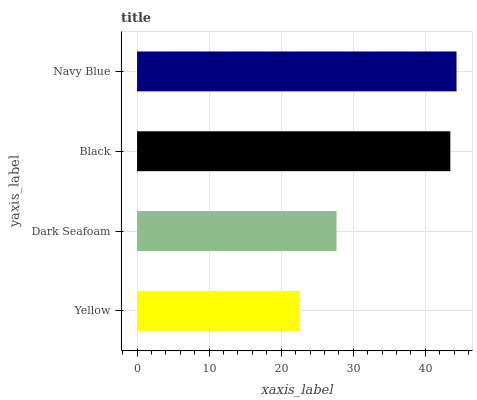Is Yellow the minimum?
Answer yes or no. Yes. Is Navy Blue the maximum?
Answer yes or no. Yes. Is Dark Seafoam the minimum?
Answer yes or no. No. Is Dark Seafoam the maximum?
Answer yes or no. No. Is Dark Seafoam greater than Yellow?
Answer yes or no. Yes. Is Yellow less than Dark Seafoam?
Answer yes or no. Yes. Is Yellow greater than Dark Seafoam?
Answer yes or no. No. Is Dark Seafoam less than Yellow?
Answer yes or no. No. Is Black the high median?
Answer yes or no. Yes. Is Dark Seafoam the low median?
Answer yes or no. Yes. Is Yellow the high median?
Answer yes or no. No. Is Black the low median?
Answer yes or no. No. 